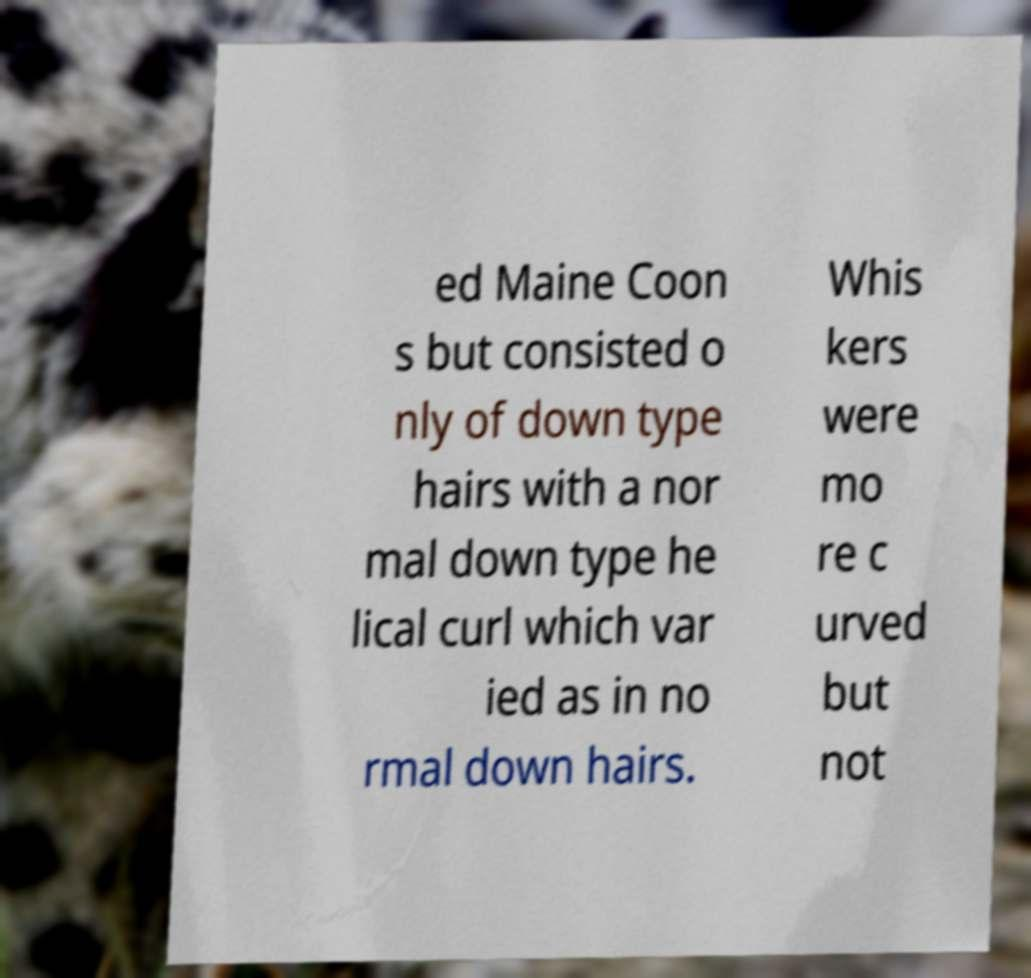Can you read and provide the text displayed in the image?This photo seems to have some interesting text. Can you extract and type it out for me? ed Maine Coon s but consisted o nly of down type hairs with a nor mal down type he lical curl which var ied as in no rmal down hairs. Whis kers were mo re c urved but not 